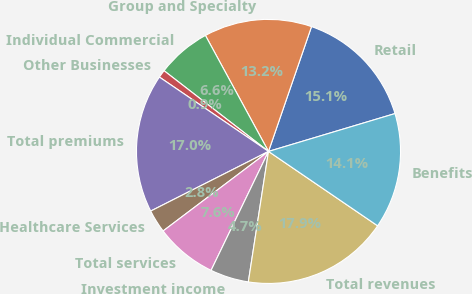<chart> <loc_0><loc_0><loc_500><loc_500><pie_chart><fcel>Retail<fcel>Group and Specialty<fcel>Individual Commercial<fcel>Other Businesses<fcel>Total premiums<fcel>Healthcare Services<fcel>Total services<fcel>Investment income<fcel>Total revenues<fcel>Benefits<nl><fcel>15.09%<fcel>13.21%<fcel>6.6%<fcel>0.95%<fcel>16.98%<fcel>2.83%<fcel>7.55%<fcel>4.72%<fcel>17.92%<fcel>14.15%<nl></chart> 